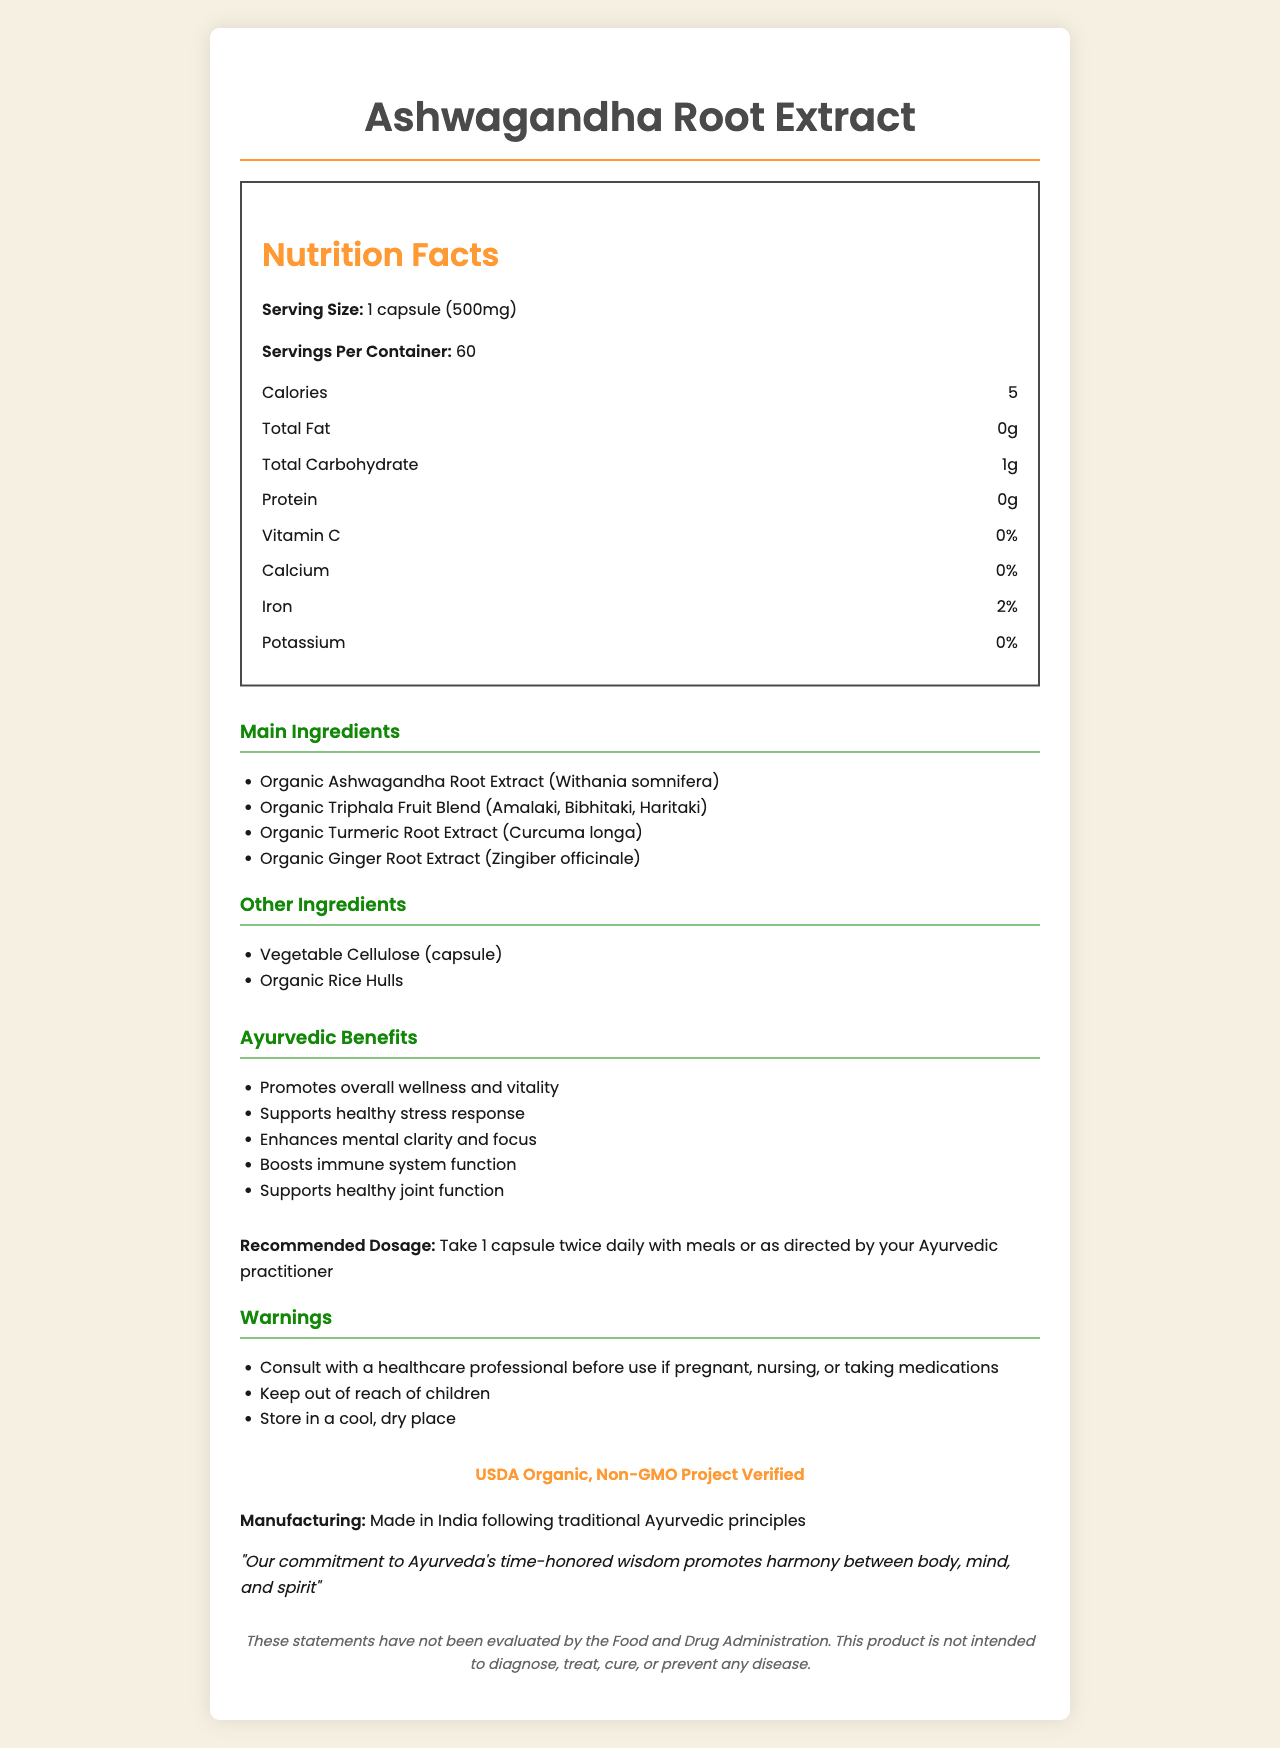what is the serving size for Ashwagandha Root Extract? The serving size is explicitly mentioned under the nutrition label as "1 capsule (500mg)".
Answer: 1 capsule (500mg) how many calories are in one serving? The document lists the calorie content per serving under the nutrition label as "Calories: 5".
Answer: 5 calories name two main ingredients in Ashwagandha Root Extract. These ingredients are listed under the "Main Ingredients" section.
Answer: Organic Ashwagandha Root Extract and Organic Triphala Fruit Blend how many servings are there per container? The number of servings per container is explicitly mentioned as 60 in the nutrition facts.
Answer: 60 what certifications does the product hold? These certifications are listed under a dedicated certification section.
Answer: USDA Organic, Non-GMO Project Verified which ingredient in the supplement is known for its anti-inflammatory properties? Turmeric is widely known for its anti-inflammatory properties and it is listed as one of the main ingredients.
Answer: Organic Turmeric Root Extract (Curcuma longa) what is the recommended dosage? This information is given under the "Recommended Dosage" section.
Answer: Take 1 capsule twice daily with meals or as directed by your Ayurvedic practitioner for whom is it advised to consult a healthcare professional before using this supplement? This warning is listed explicitly under the "Warnings" section.
Answer: Those who are pregnant, nursing, or taking medications what benefits does the product claim to offer for joint function? A. Enhances mental clarity B. Supports healthy joint function C. Boosts immune system function D. Promotes vitality "Supports healthy joint function" is listed as one of the Ayurvedic benefits.
Answer: B what dietary percentage of iron is provided in one serving? Under the "Nutrition Facts" section, it mentions that the iron content per serving is 2%.
Answer: 2% does the product include any artificial ingredients or fillers? The document lists only natural ingredients under "Main Ingredients" and "Other Ingredients". There is no mention of any artificial ingredients or fillers.
Answer: No who manufactures the Ashwagandha Root Extract supplement? A. Made in India B. Made in China C. Made in USA D. Made in Germany The manufacturing information clearly states that it is "Made in India following traditional Ayurvedic principles".
Answer: A is the product intended to diagnose, treat, cure, or prevent any disease? The disclaimer explicitly states that it is not intended to diagnose, treat, cure, or prevent any disease.
Answer: No what are the main ingredients and benefits of the Ashwagandha Root Extract supplement? The document provides a detailed list of both the main ingredients and the Ayurvedic benefits.
Answer: The main ingredients are Organic Ashwagandha Root Extract, Organic Triphala Fruit Blend, Organic Turmeric Root Extract, and Organic Ginger Root Extract. The benefits include promoting overall wellness and vitality, supporting healthy stress response, enhancing mental clarity and focus, boosting immune system function, and supporting healthy joint function. where should the Ashwagandha Root Extract supplement be stored? The warning section specifies to "Store in a cool, dry place."
Answer: In a cool, dry place what is the most important visual element in the document regarding the composition of the capsule? The document provides detailed information about ingredients and composition but does not specify which is the "most important" visual element regarding composition.
Answer: Cannot be determined what percentage of daily calcium is found in one serving of Ashwagandha Root Extract? Under the "Nutrition Facts" section, it mentions that the calcium content per serving is 0%.
Answer: 0% describe the entire document. The document is structured to offer a complete overview of the supplement, covering all essential aspects related to its use, benefits, and safety.
Answer: The document provides comprehensive information about a popular Ayurvedic health supplement named "Ashwagandha Root Extract". It includes the product name, serving size, servings per container, nutritional facts (calories, fats, carbohydrates, protein, vitamins, etc.), main and other ingredients, Ayurvedic benefits, recommended dosage, warnings, certifications, manufacturing details, a company statement, and a disclaimer. The visual presentation is clean, with sections clearly demarcated, facilitating easy reading and understanding of the information provided. 